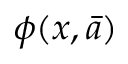Convert formula to latex. <formula><loc_0><loc_0><loc_500><loc_500>\phi ( x , { \bar { a } } )</formula> 